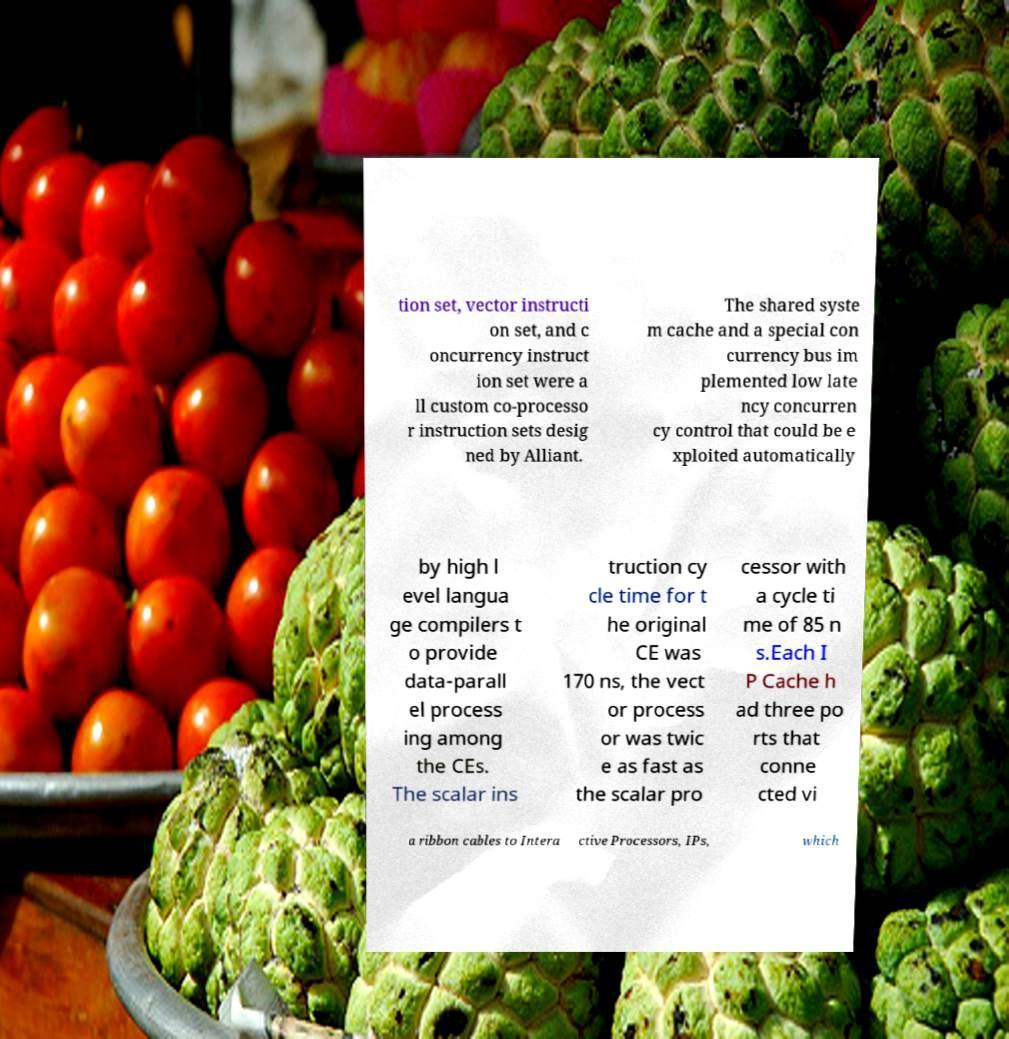Could you assist in decoding the text presented in this image and type it out clearly? tion set, vector instructi on set, and c oncurrency instruct ion set were a ll custom co-processo r instruction sets desig ned by Alliant. The shared syste m cache and a special con currency bus im plemented low late ncy concurren cy control that could be e xploited automatically by high l evel langua ge compilers t o provide data-parall el process ing among the CEs. The scalar ins truction cy cle time for t he original CE was 170 ns, the vect or process or was twic e as fast as the scalar pro cessor with a cycle ti me of 85 n s.Each I P Cache h ad three po rts that conne cted vi a ribbon cables to Intera ctive Processors, IPs, which 